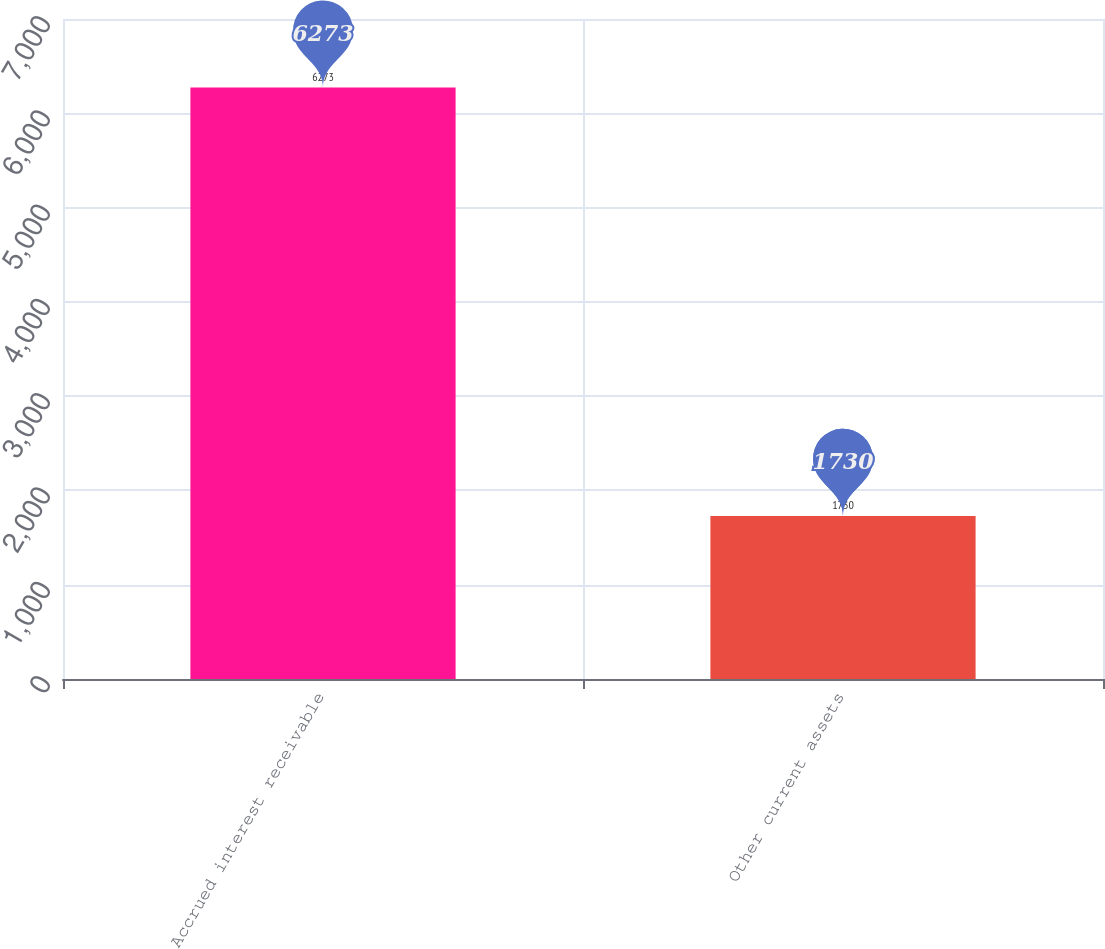Convert chart. <chart><loc_0><loc_0><loc_500><loc_500><bar_chart><fcel>Accrued interest receivable<fcel>Other current assets<nl><fcel>6273<fcel>1730<nl></chart> 